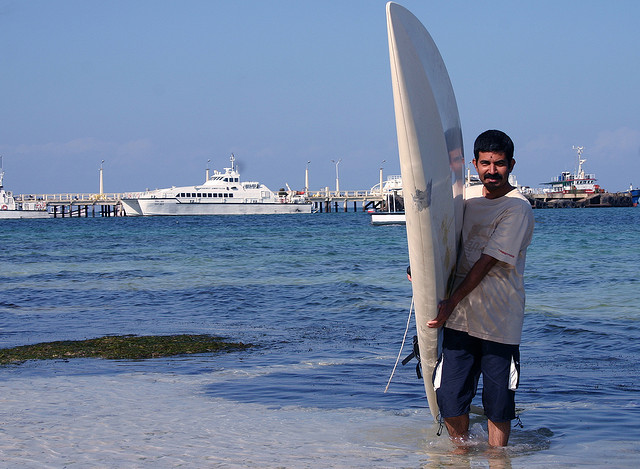<image>What is tied to the surfboard? I am not sure what is tied to the surfboard, it can be a surfer, netting, leash, string, rider, or nothing at all. What is tied to the surfboard? I am not sure what is tied to the surfboard. It could be netting, leash, string, or something else. 